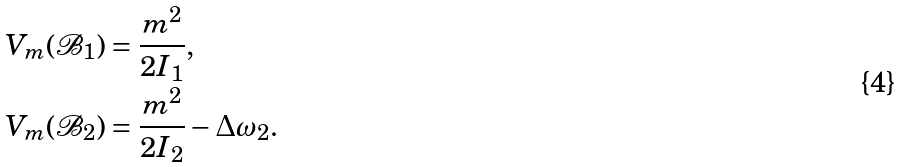Convert formula to latex. <formula><loc_0><loc_0><loc_500><loc_500>V _ { m } ( \mathcal { B } _ { 1 } ) & = \frac { m ^ { 2 } } { 2 I _ { 1 } } , \\ V _ { m } ( \mathcal { B } _ { 2 } ) & = \frac { m ^ { 2 } } { 2 I _ { 2 } } - \Delta \omega _ { 2 } .</formula> 